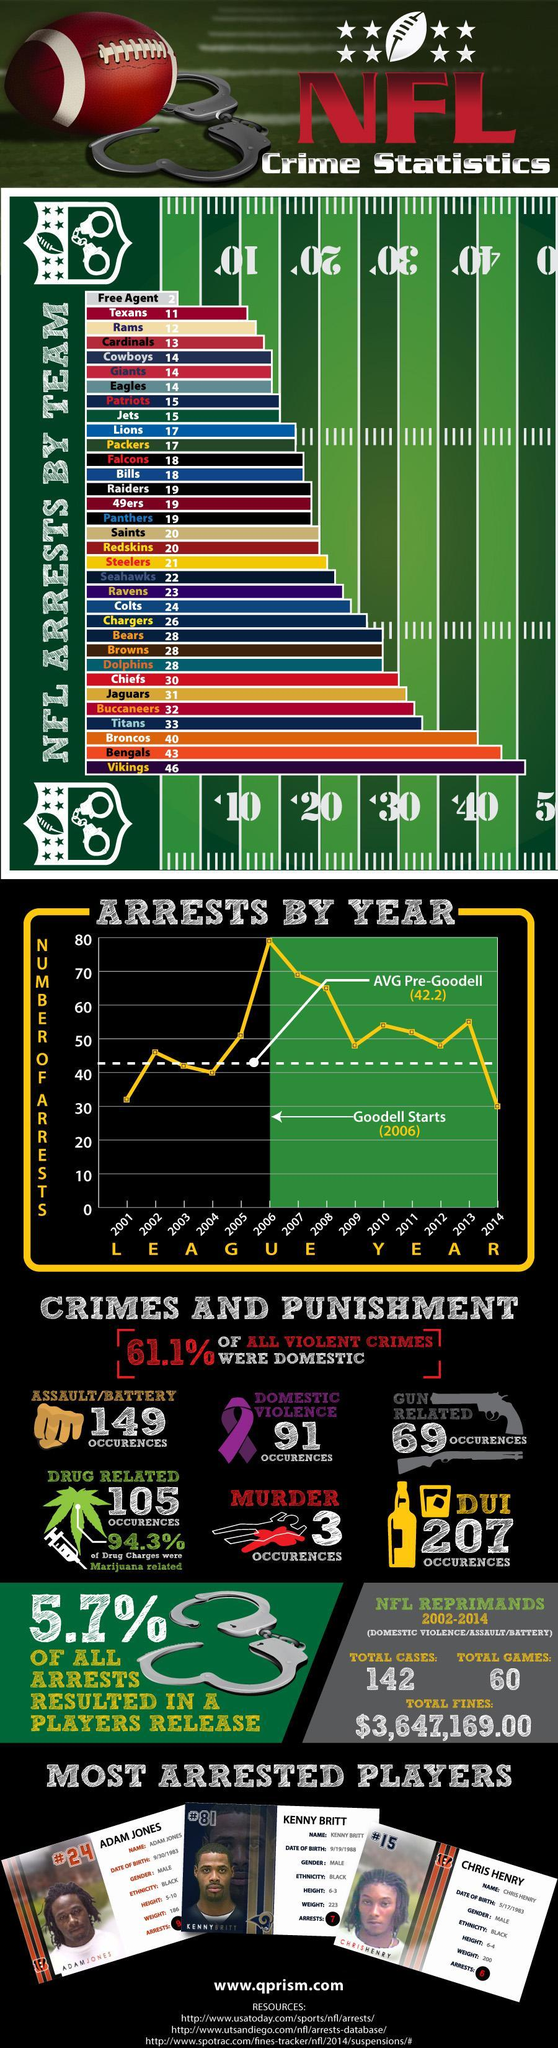How many times Chris Henry has been arrested?
Answer the question with a short phrase. 6 How many Patriots players have been arrested since 2000? 15 Which league year has seen the highest number of NFL arrests since 2000? 2006 Which NFL team has reported the highest number of arrests since 2000? Vikings What is the main reason for NFL players arrests? DUI How many NFL arrests were made due to domestic violence? 91 Which NFL team has reported the second-highest number of arrests since 2000? Bengals How many Packers players have been arrested since 2000? 17 